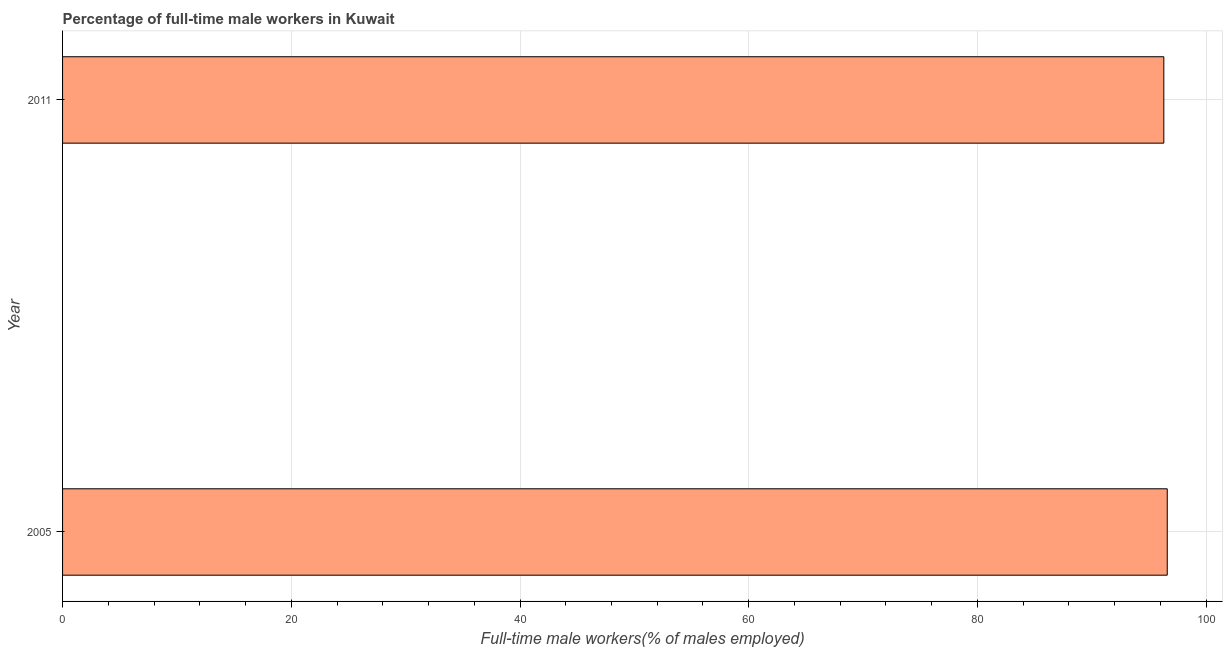Does the graph contain grids?
Your answer should be very brief. Yes. What is the title of the graph?
Give a very brief answer. Percentage of full-time male workers in Kuwait. What is the label or title of the X-axis?
Your response must be concise. Full-time male workers(% of males employed). What is the label or title of the Y-axis?
Your answer should be very brief. Year. What is the percentage of full-time male workers in 2011?
Provide a succinct answer. 96.3. Across all years, what is the maximum percentage of full-time male workers?
Ensure brevity in your answer.  96.6. Across all years, what is the minimum percentage of full-time male workers?
Your answer should be compact. 96.3. In which year was the percentage of full-time male workers minimum?
Offer a very short reply. 2011. What is the sum of the percentage of full-time male workers?
Provide a succinct answer. 192.9. What is the difference between the percentage of full-time male workers in 2005 and 2011?
Your answer should be very brief. 0.3. What is the average percentage of full-time male workers per year?
Offer a very short reply. 96.45. What is the median percentage of full-time male workers?
Ensure brevity in your answer.  96.45. In how many years, is the percentage of full-time male workers greater than 80 %?
Make the answer very short. 2. Is the percentage of full-time male workers in 2005 less than that in 2011?
Ensure brevity in your answer.  No. In how many years, is the percentage of full-time male workers greater than the average percentage of full-time male workers taken over all years?
Your answer should be very brief. 1. How many years are there in the graph?
Your response must be concise. 2. What is the difference between two consecutive major ticks on the X-axis?
Provide a succinct answer. 20. Are the values on the major ticks of X-axis written in scientific E-notation?
Provide a short and direct response. No. What is the Full-time male workers(% of males employed) of 2005?
Offer a terse response. 96.6. What is the Full-time male workers(% of males employed) in 2011?
Provide a short and direct response. 96.3. 